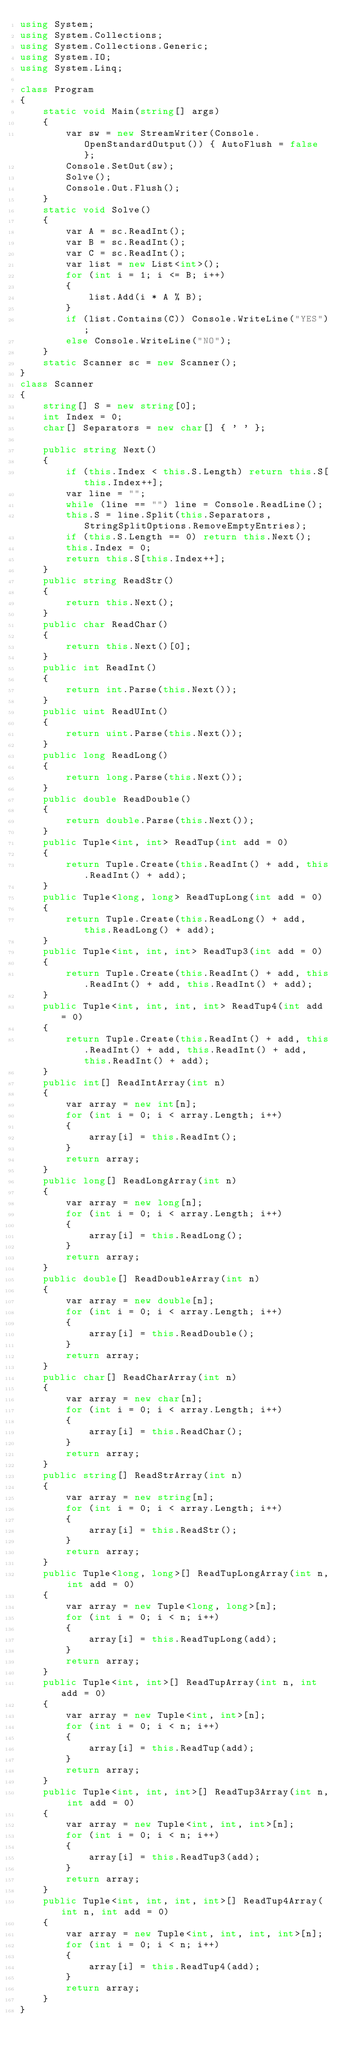Convert code to text. <code><loc_0><loc_0><loc_500><loc_500><_C#_>using System;
using System.Collections;
using System.Collections.Generic;
using System.IO;
using System.Linq;

class Program
{
    static void Main(string[] args)
    {
        var sw = new StreamWriter(Console.OpenStandardOutput()) { AutoFlush = false };
        Console.SetOut(sw);
        Solve();
        Console.Out.Flush();
    }
    static void Solve()
    {
        var A = sc.ReadInt();
        var B = sc.ReadInt();
        var C = sc.ReadInt();
        var list = new List<int>();
        for (int i = 1; i <= B; i++)
        {
            list.Add(i * A % B);
        }
        if (list.Contains(C)) Console.WriteLine("YES");
        else Console.WriteLine("NO");
    }
    static Scanner sc = new Scanner();
}
class Scanner
{
    string[] S = new string[0];
    int Index = 0;
    char[] Separators = new char[] { ' ' };

    public string Next()
    {
        if (this.Index < this.S.Length) return this.S[this.Index++];
        var line = "";
        while (line == "") line = Console.ReadLine();
        this.S = line.Split(this.Separators, StringSplitOptions.RemoveEmptyEntries);
        if (this.S.Length == 0) return this.Next();
        this.Index = 0;
        return this.S[this.Index++];
    }
    public string ReadStr()
    {
        return this.Next();
    }
    public char ReadChar()
    {
        return this.Next()[0];
    }
    public int ReadInt()
    {
        return int.Parse(this.Next());
    }
    public uint ReadUInt()
    {
        return uint.Parse(this.Next());
    }
    public long ReadLong()
    {
        return long.Parse(this.Next());
    }
    public double ReadDouble()
    {
        return double.Parse(this.Next());
    }
    public Tuple<int, int> ReadTup(int add = 0)
    {
        return Tuple.Create(this.ReadInt() + add, this.ReadInt() + add);
    }
    public Tuple<long, long> ReadTupLong(int add = 0)
    {
        return Tuple.Create(this.ReadLong() + add, this.ReadLong() + add);
    }
    public Tuple<int, int, int> ReadTup3(int add = 0)
    {
        return Tuple.Create(this.ReadInt() + add, this.ReadInt() + add, this.ReadInt() + add);
    }
    public Tuple<int, int, int, int> ReadTup4(int add = 0)
    {
        return Tuple.Create(this.ReadInt() + add, this.ReadInt() + add, this.ReadInt() + add, this.ReadInt() + add);
    }
    public int[] ReadIntArray(int n)
    {
        var array = new int[n];
        for (int i = 0; i < array.Length; i++)
        {
            array[i] = this.ReadInt();
        }
        return array;
    }
    public long[] ReadLongArray(int n)
    {
        var array = new long[n];
        for (int i = 0; i < array.Length; i++)
        {
            array[i] = this.ReadLong();
        }
        return array;
    }
    public double[] ReadDoubleArray(int n)
    {
        var array = new double[n];
        for (int i = 0; i < array.Length; i++)
        {
            array[i] = this.ReadDouble();
        }
        return array;
    }
    public char[] ReadCharArray(int n)
    {
        var array = new char[n];
        for (int i = 0; i < array.Length; i++)
        {
            array[i] = this.ReadChar();
        }
        return array;
    }
    public string[] ReadStrArray(int n)
    {
        var array = new string[n];
        for (int i = 0; i < array.Length; i++)
        {
            array[i] = this.ReadStr();
        }
        return array;
    }
    public Tuple<long, long>[] ReadTupLongArray(int n, int add = 0)
    {
        var array = new Tuple<long, long>[n];
        for (int i = 0; i < n; i++)
        {
            array[i] = this.ReadTupLong(add);
        }
        return array;
    }
    public Tuple<int, int>[] ReadTupArray(int n, int add = 0)
    {
        var array = new Tuple<int, int>[n];
        for (int i = 0; i < n; i++)
        {
            array[i] = this.ReadTup(add);
        }
        return array;
    }
    public Tuple<int, int, int>[] ReadTup3Array(int n, int add = 0)
    {
        var array = new Tuple<int, int, int>[n];
        for (int i = 0; i < n; i++)
        {
            array[i] = this.ReadTup3(add);
        }
        return array;
    }
    public Tuple<int, int, int, int>[] ReadTup4Array(int n, int add = 0)
    {
        var array = new Tuple<int, int, int, int>[n];
        for (int i = 0; i < n; i++)
        {
            array[i] = this.ReadTup4(add);
        }
        return array;
    }
}
</code> 